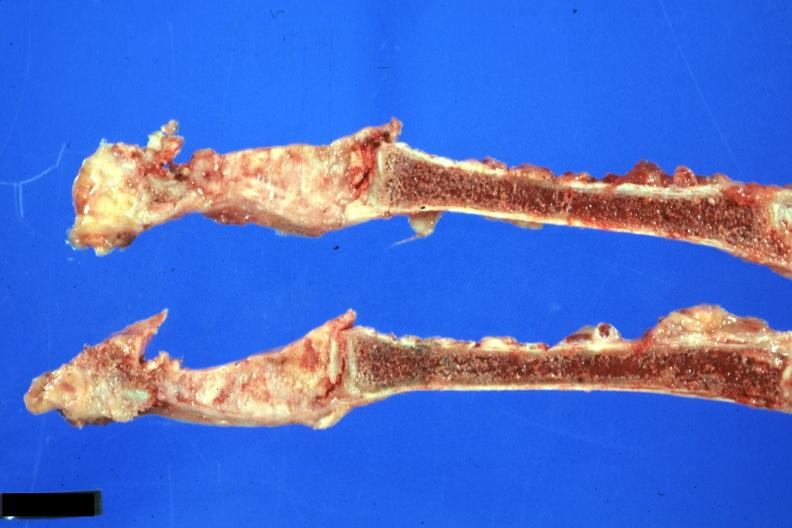what is present?
Answer the question using a single word or phrase. Joints 